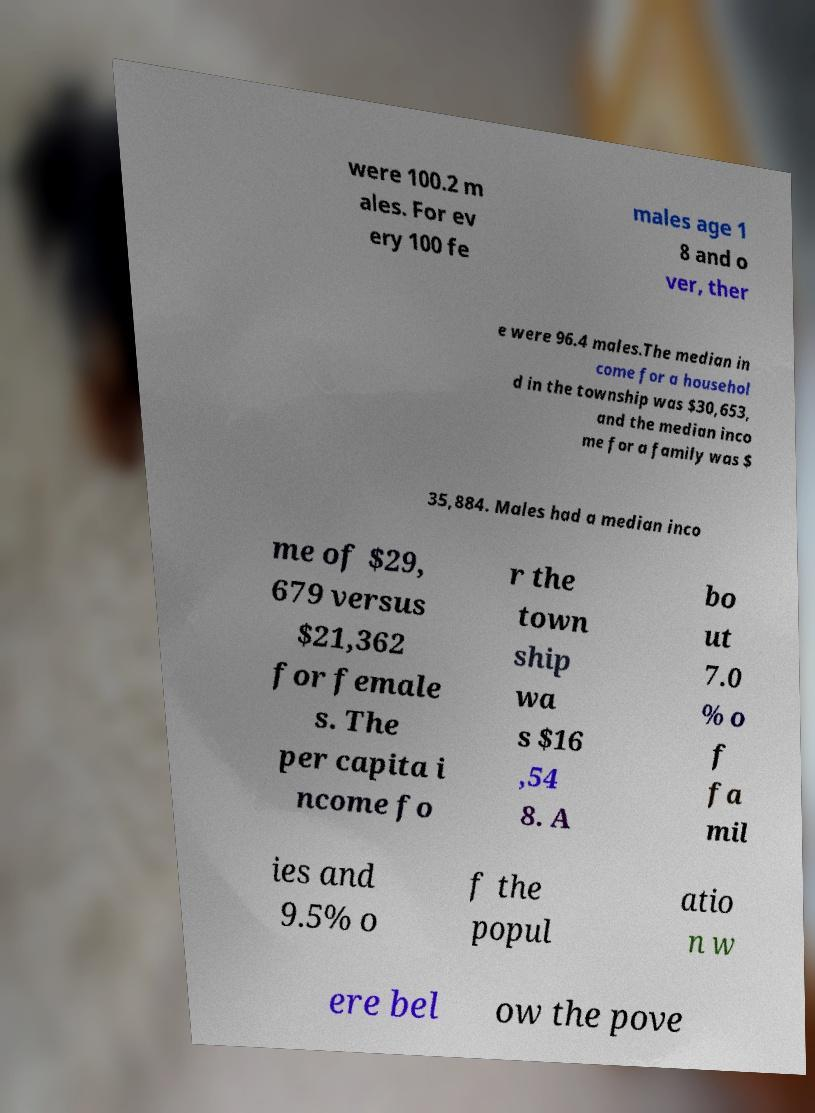There's text embedded in this image that I need extracted. Can you transcribe it verbatim? were 100.2 m ales. For ev ery 100 fe males age 1 8 and o ver, ther e were 96.4 males.The median in come for a househol d in the township was $30,653, and the median inco me for a family was $ 35,884. Males had a median inco me of $29, 679 versus $21,362 for female s. The per capita i ncome fo r the town ship wa s $16 ,54 8. A bo ut 7.0 % o f fa mil ies and 9.5% o f the popul atio n w ere bel ow the pove 